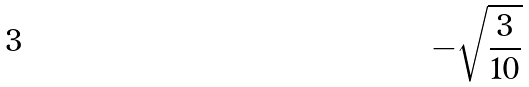Convert formula to latex. <formula><loc_0><loc_0><loc_500><loc_500>- \sqrt { \frac { 3 } { 1 0 } }</formula> 